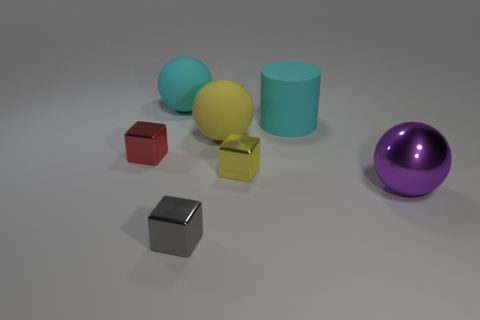Is the material of the large cylinder the same as the large object in front of the small yellow metal thing?
Keep it short and to the point. No. There is a yellow thing behind the red block; what material is it?
Offer a very short reply. Rubber. There is a cyan object that is on the right side of the small cube on the right side of the big yellow rubber ball; what is it made of?
Your answer should be compact. Rubber. What number of things have the same color as the big cylinder?
Provide a succinct answer. 1. There is a yellow object on the right side of the yellow rubber object; does it have the same size as the cyan matte thing that is on the left side of the big yellow ball?
Make the answer very short. No. What is the color of the object that is in front of the large ball in front of the large matte sphere that is right of the big cyan rubber ball?
Make the answer very short. Gray. Are there any yellow matte objects that have the same shape as the purple metallic object?
Offer a very short reply. Yes. Is the number of large purple things behind the large yellow matte sphere the same as the number of large metal spheres that are on the left side of the small gray block?
Your answer should be compact. Yes. Does the small object behind the yellow metal block have the same shape as the yellow shiny object?
Your response must be concise. Yes. Do the red metal thing and the tiny yellow thing have the same shape?
Give a very brief answer. Yes. 